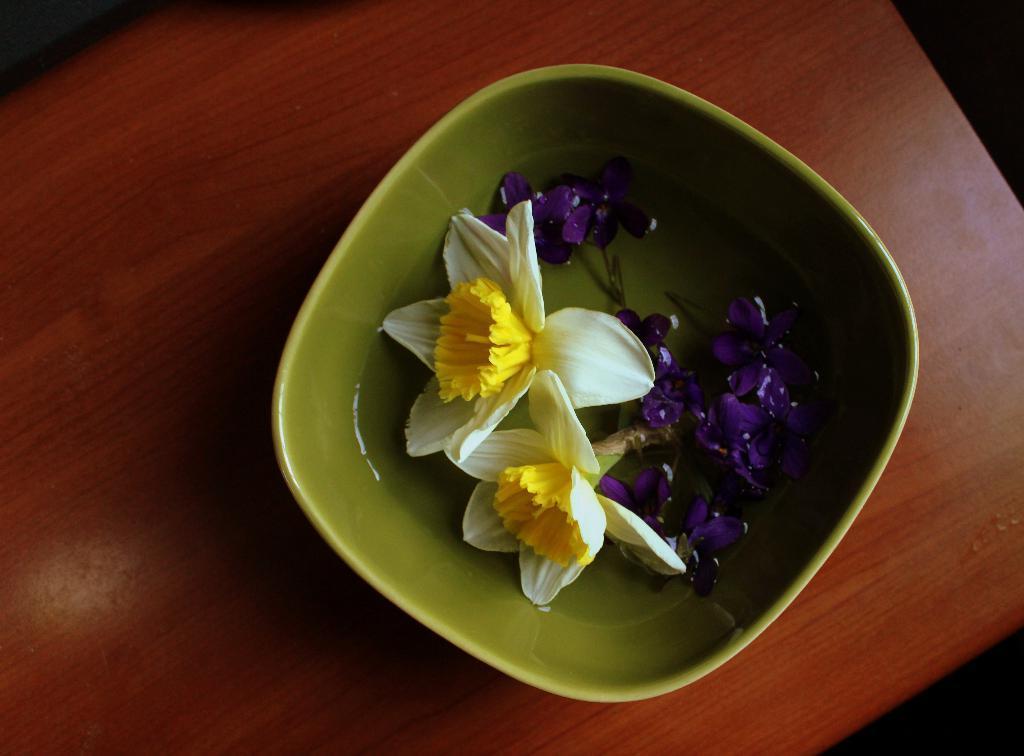In one or two sentences, can you explain what this image depicts? In this image we can see a green color bowl in which flowers and water kept, which is placed on the wooden table. 